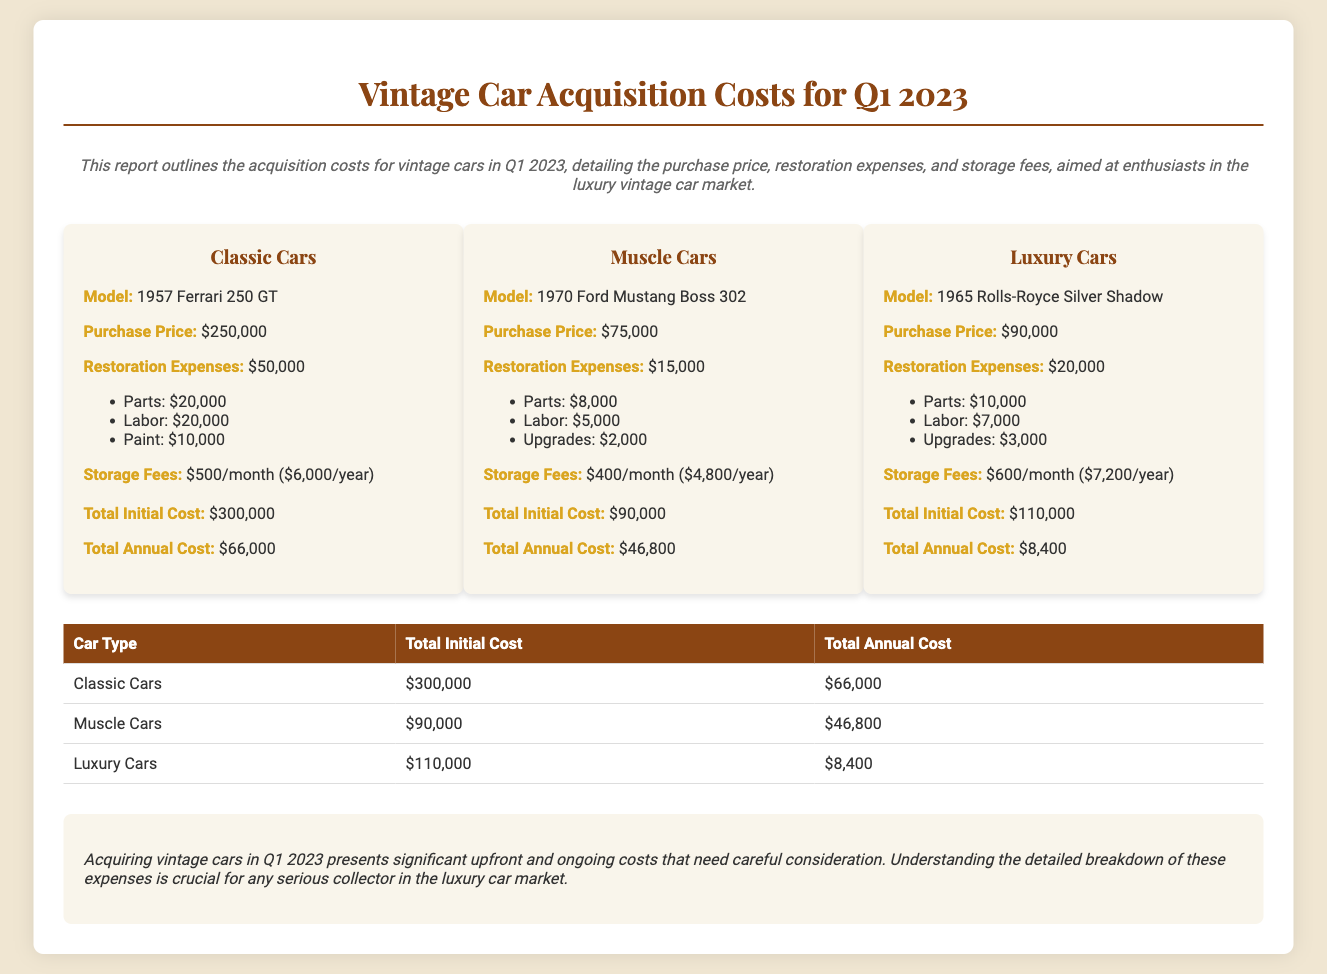What is the purchase price of the 1957 Ferrari 250 GT? The purchase price is explicitly stated in the document as $250,000.
Answer: $250,000 What are the restoration expenses for the 1965 Rolls-Royce Silver Shadow? The restoration expenses total $20,000 according to the breakdown provided in the document.
Answer: $20,000 What is the total initial cost for Muscle Cars? The document lists the total initial cost for Muscle Cars as $90,000.
Answer: $90,000 What are the monthly storage fees for the Classic Cars? Storage fees for Classic Cars are mentioned as $500/month in the report.
Answer: $500/month Which car has the highest total annual cost? A careful comparison of the total annual costs reveals that Classic Cars incur the highest cost at $66,000.
Answer: Classic Cars What is the combined total initial cost for all three car types? The total initial costs are $300,000 (Classic) + $90,000 (Muscle) + $110,000 (Luxury), giving a total of $500,000.
Answer: $500,000 What is the model of the Muscle Car mentioned? The model for the Muscle Car specified in the document is the 1970 Ford Mustang Boss 302.
Answer: 1970 Ford Mustang Boss 302 What is the total annual cost of the 1965 Rolls-Royce Silver Shadow? The report indicates the total annual cost of the 1965 Rolls-Royce Silver Shadow as $8,400.
Answer: $8,400 What type of report is this document classified as? The document provides financial insights specifically about vintage cars, classifying it as a financial report.
Answer: Financial report 